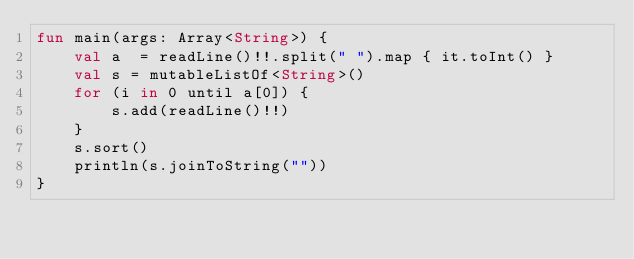<code> <loc_0><loc_0><loc_500><loc_500><_Kotlin_>fun main(args: Array<String>) {
    val a  = readLine()!!.split(" ").map { it.toInt() }
    val s = mutableListOf<String>()
    for (i in 0 until a[0]) {
        s.add(readLine()!!)
    }
    s.sort()
    println(s.joinToString(""))
}

</code> 